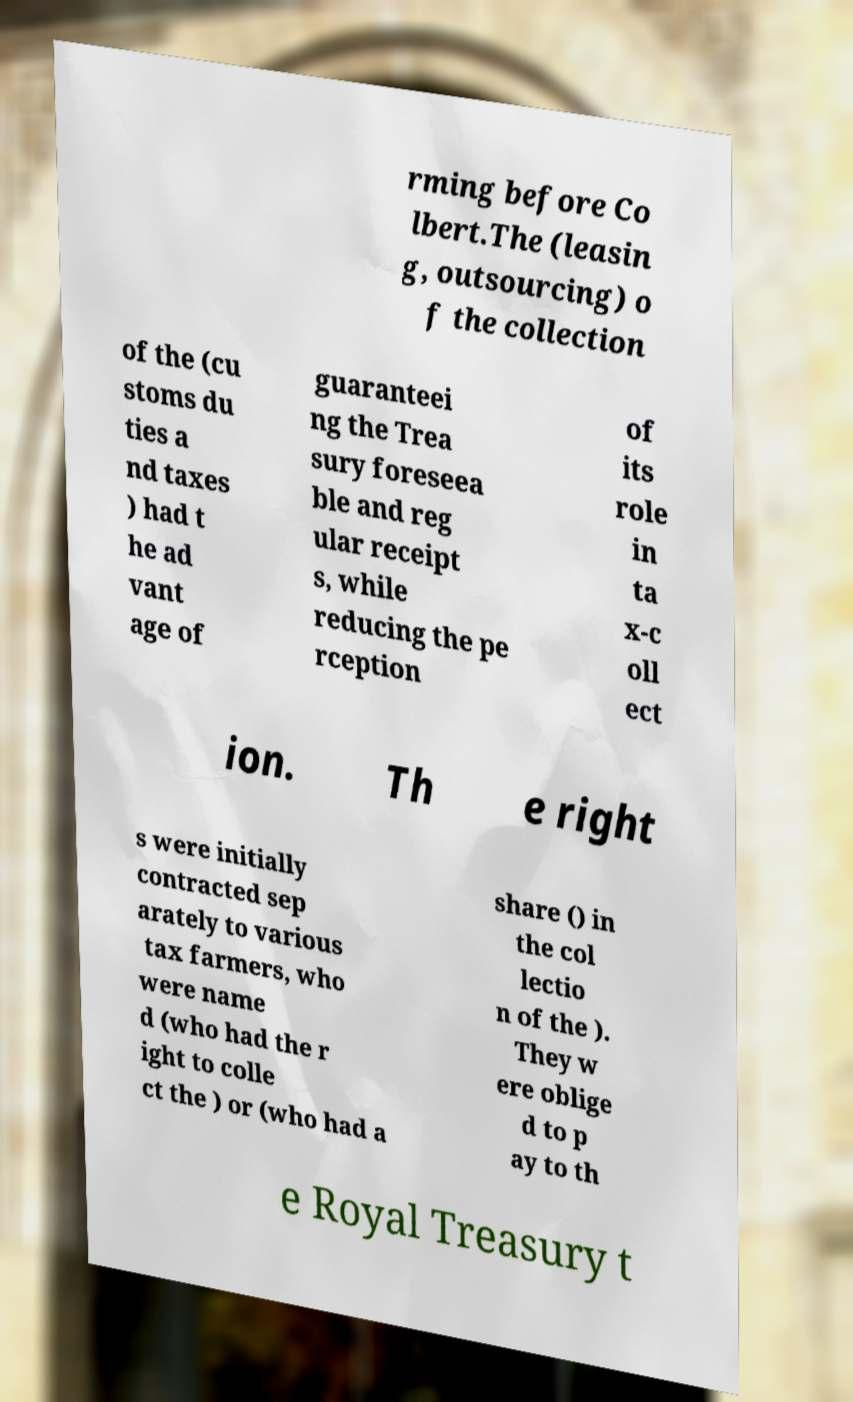Can you accurately transcribe the text from the provided image for me? rming before Co lbert.The (leasin g, outsourcing) o f the collection of the (cu stoms du ties a nd taxes ) had t he ad vant age of guaranteei ng the Trea sury foreseea ble and reg ular receipt s, while reducing the pe rception of its role in ta x-c oll ect ion. Th e right s were initially contracted sep arately to various tax farmers, who were name d (who had the r ight to colle ct the ) or (who had a share () in the col lectio n of the ). They w ere oblige d to p ay to th e Royal Treasury t 